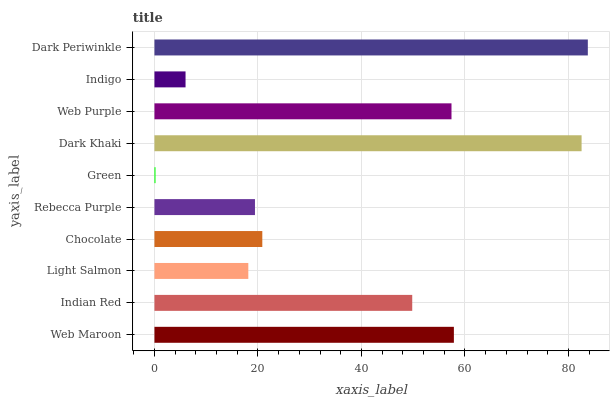Is Green the minimum?
Answer yes or no. Yes. Is Dark Periwinkle the maximum?
Answer yes or no. Yes. Is Indian Red the minimum?
Answer yes or no. No. Is Indian Red the maximum?
Answer yes or no. No. Is Web Maroon greater than Indian Red?
Answer yes or no. Yes. Is Indian Red less than Web Maroon?
Answer yes or no. Yes. Is Indian Red greater than Web Maroon?
Answer yes or no. No. Is Web Maroon less than Indian Red?
Answer yes or no. No. Is Indian Red the high median?
Answer yes or no. Yes. Is Chocolate the low median?
Answer yes or no. Yes. Is Rebecca Purple the high median?
Answer yes or no. No. Is Dark Khaki the low median?
Answer yes or no. No. 